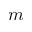Convert formula to latex. <formula><loc_0><loc_0><loc_500><loc_500>m</formula> 